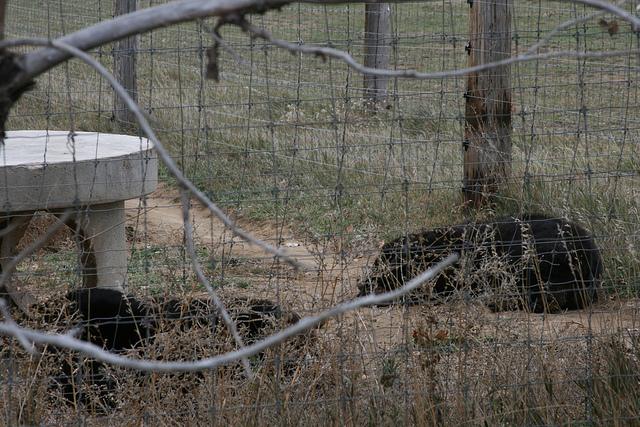In the animal in a fence?
Concise answer only. Yes. What animal does that look like?
Give a very brief answer. Bear. What is the animal doing?
Answer briefly. Sleeping. 